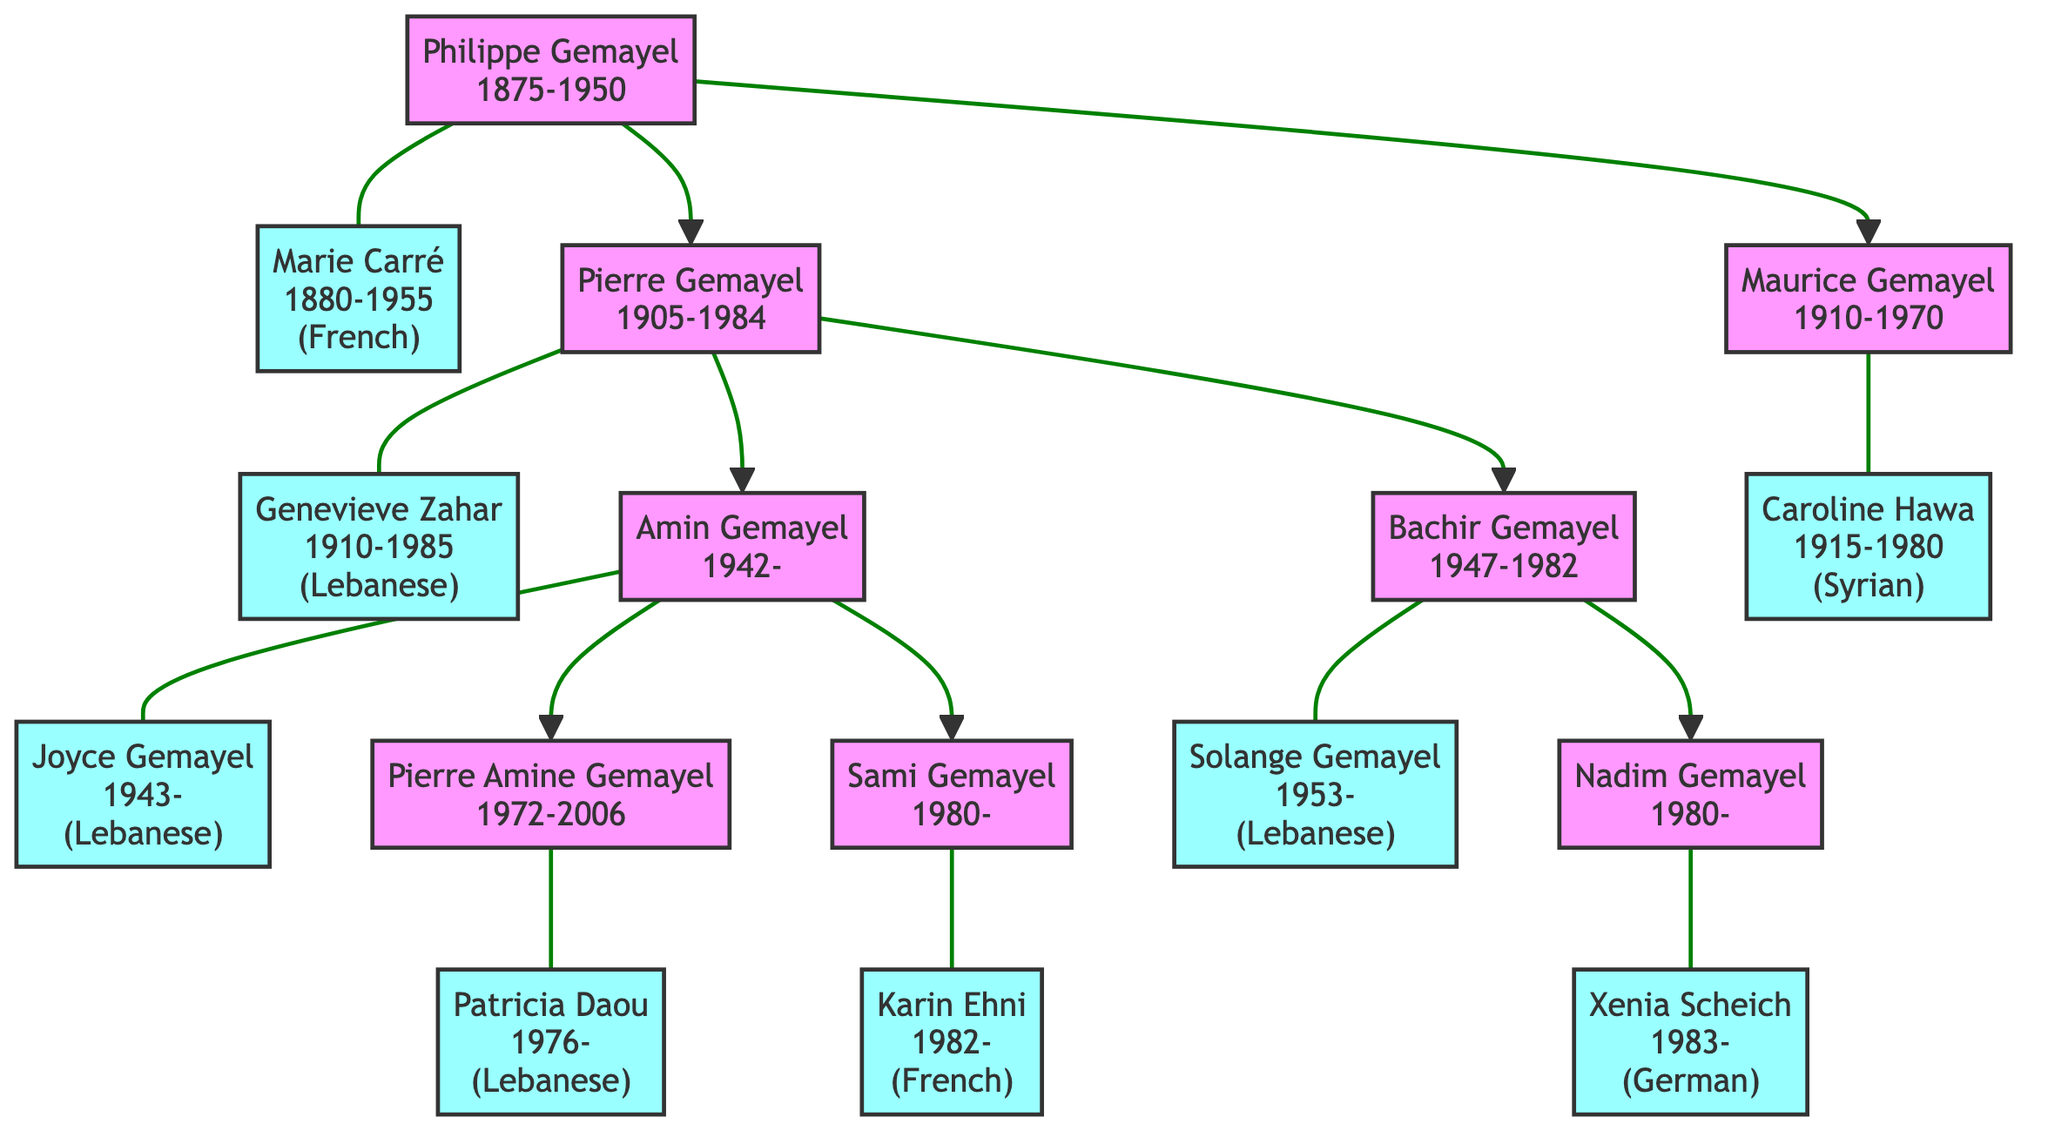What is the nationality of Marie Carré? Marie Carré is listed in the diagram with the note "(French)" next to her name, indicating that her nationality is French.
Answer: French Who are the children of Pierre Gemayel? The diagram shows that Pierre Gemayel has two children listed: Amin Gemayel and Bachir Gemayel, as indicated by the connecting lines from his node to their respective nodes.
Answer: Amin Gemayel, Bachir Gemayel How many generations are depicted in this family tree? The tree starts from Philippe Gemayel as the first generation, through Pierre Gemayel and Maurice Gemayel as the second generation, to Amin Gemayel and others as the third generation. Counting these, there are three generations in total.
Answer: 3 What is the nationality of Sami Gemayel's spouse? The diagram states that Sami Gemayel's spouse is Karin Ehni, noted with "(French)" next to her name, which indicates her nationality is French.
Answer: French Which child of Amin Gemayel is associated with the year 2006? The diagram shows that Pierre Amine Gemayel is noted as having the years 1972-2006. He is the child of Amin Gemayel, thus he is associated with that year.
Answer: Pierre Amine Gemayel How many spouses have non-Lebanese nationalities in this family tree? By checking the spouses listed in the diagram, Marie Carré is French, Karin Ehni is French, Xenia Scheich is German, and Caroline Hawa is Syrian. Therefore, there are four spouses with non-Lebanese nationalities.
Answer: 4 Who is the only child of Bachir Gemayel? The diagram shows that Bachir Gemayel has one child listed, Nadim Gemayel, who is directly connected to his node, indicating he is the only child.
Answer: Nadim Gemayel Which generation does Maurice Gemayel belong to? Maurice Gemayel is the child of Philippe Gemayel, placing him in the second generation according to the structure of the family tree.
Answer: 2 What is the birth year of Nadim Gemayel? The diagram explicitly states that Nadim Gemayel was born in the year 1980, as highlighted in the node containing his information.
Answer: 1980 